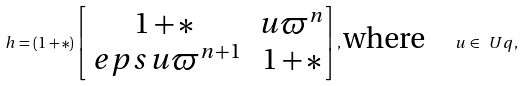Convert formula to latex. <formula><loc_0><loc_0><loc_500><loc_500>h = ( 1 + \ast ) \left [ \begin{matrix} 1 + \ast & u \varpi ^ { n } \\ \ e p s u \varpi ^ { n + 1 } & 1 + \ast \end{matrix} \right ] , \text {where} \quad u \in \ U q ,</formula> 